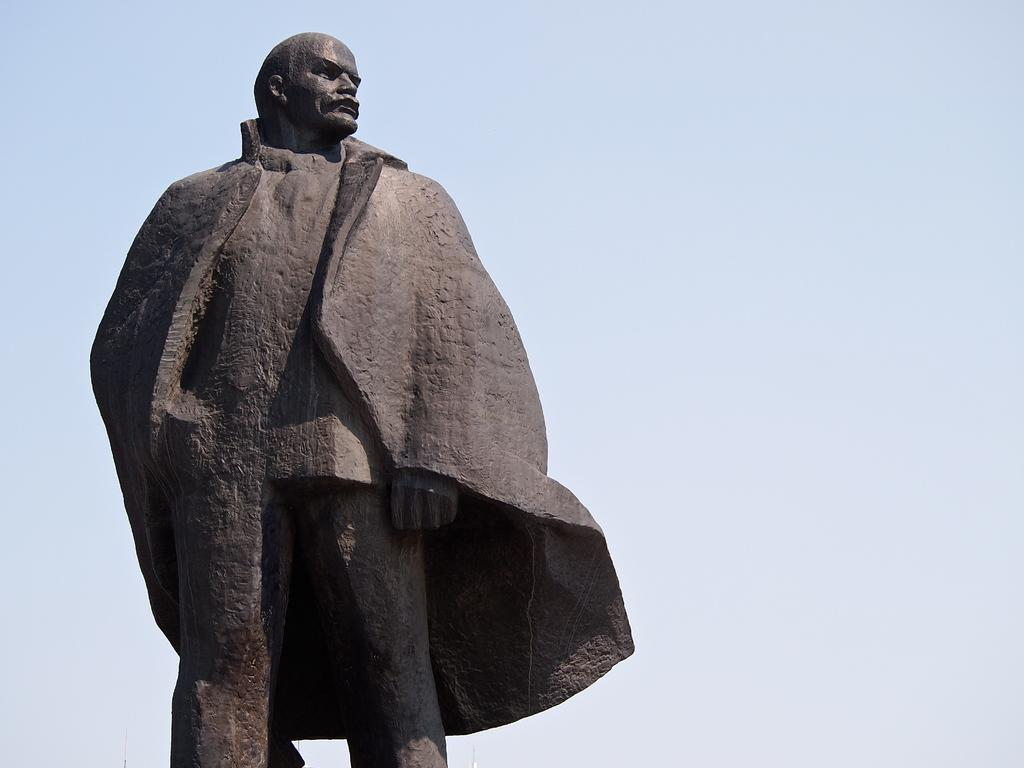What is the main subject in the center of the image? There is a statue in the center of the image. What color is the statue? The statue is black in color. What can be seen in the background of the image? There is a sky visible in the background of the image. How does the statue sort items in the image? The statue does not sort items in the image, as it is a statue and cannot perform actions. 